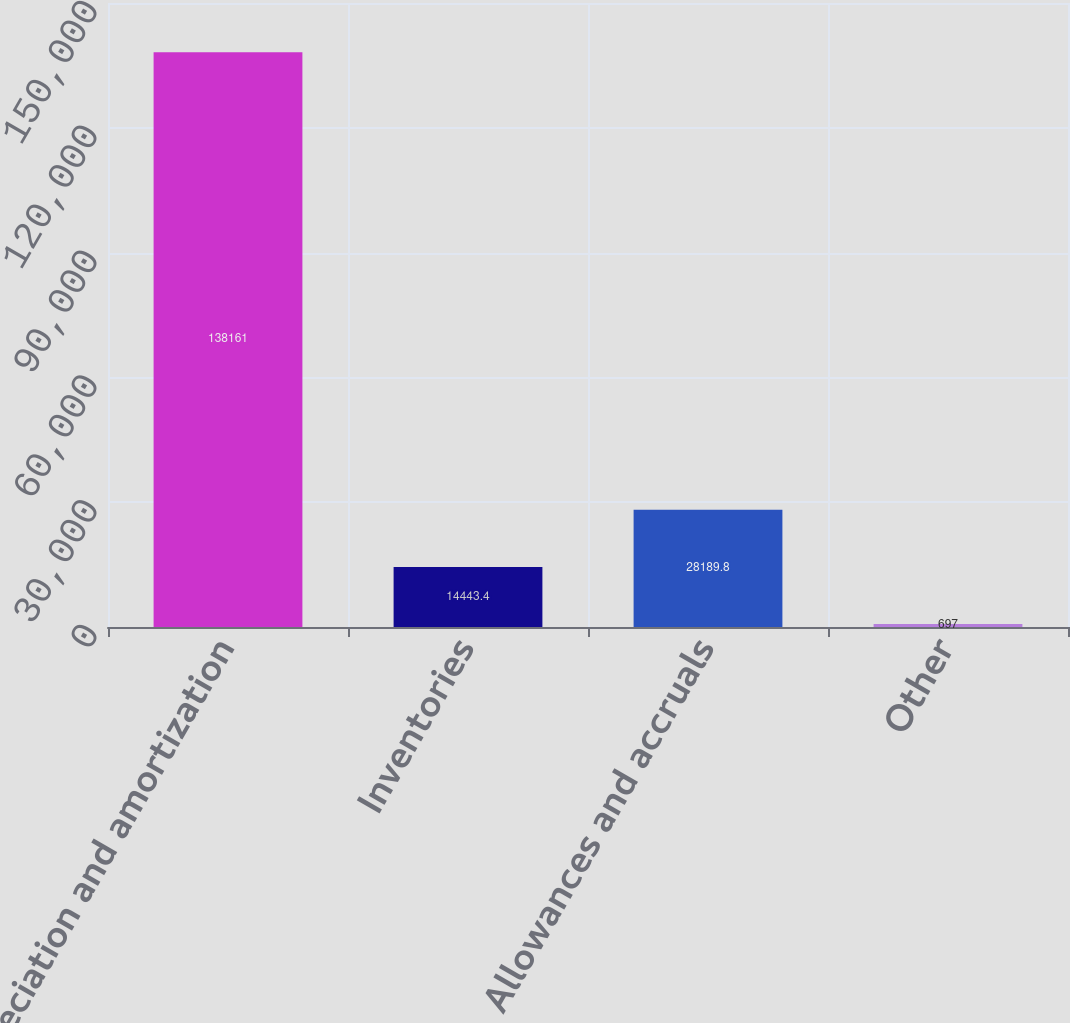Convert chart to OTSL. <chart><loc_0><loc_0><loc_500><loc_500><bar_chart><fcel>Depreciation and amortization<fcel>Inventories<fcel>Allowances and accruals<fcel>Other<nl><fcel>138161<fcel>14443.4<fcel>28189.8<fcel>697<nl></chart> 